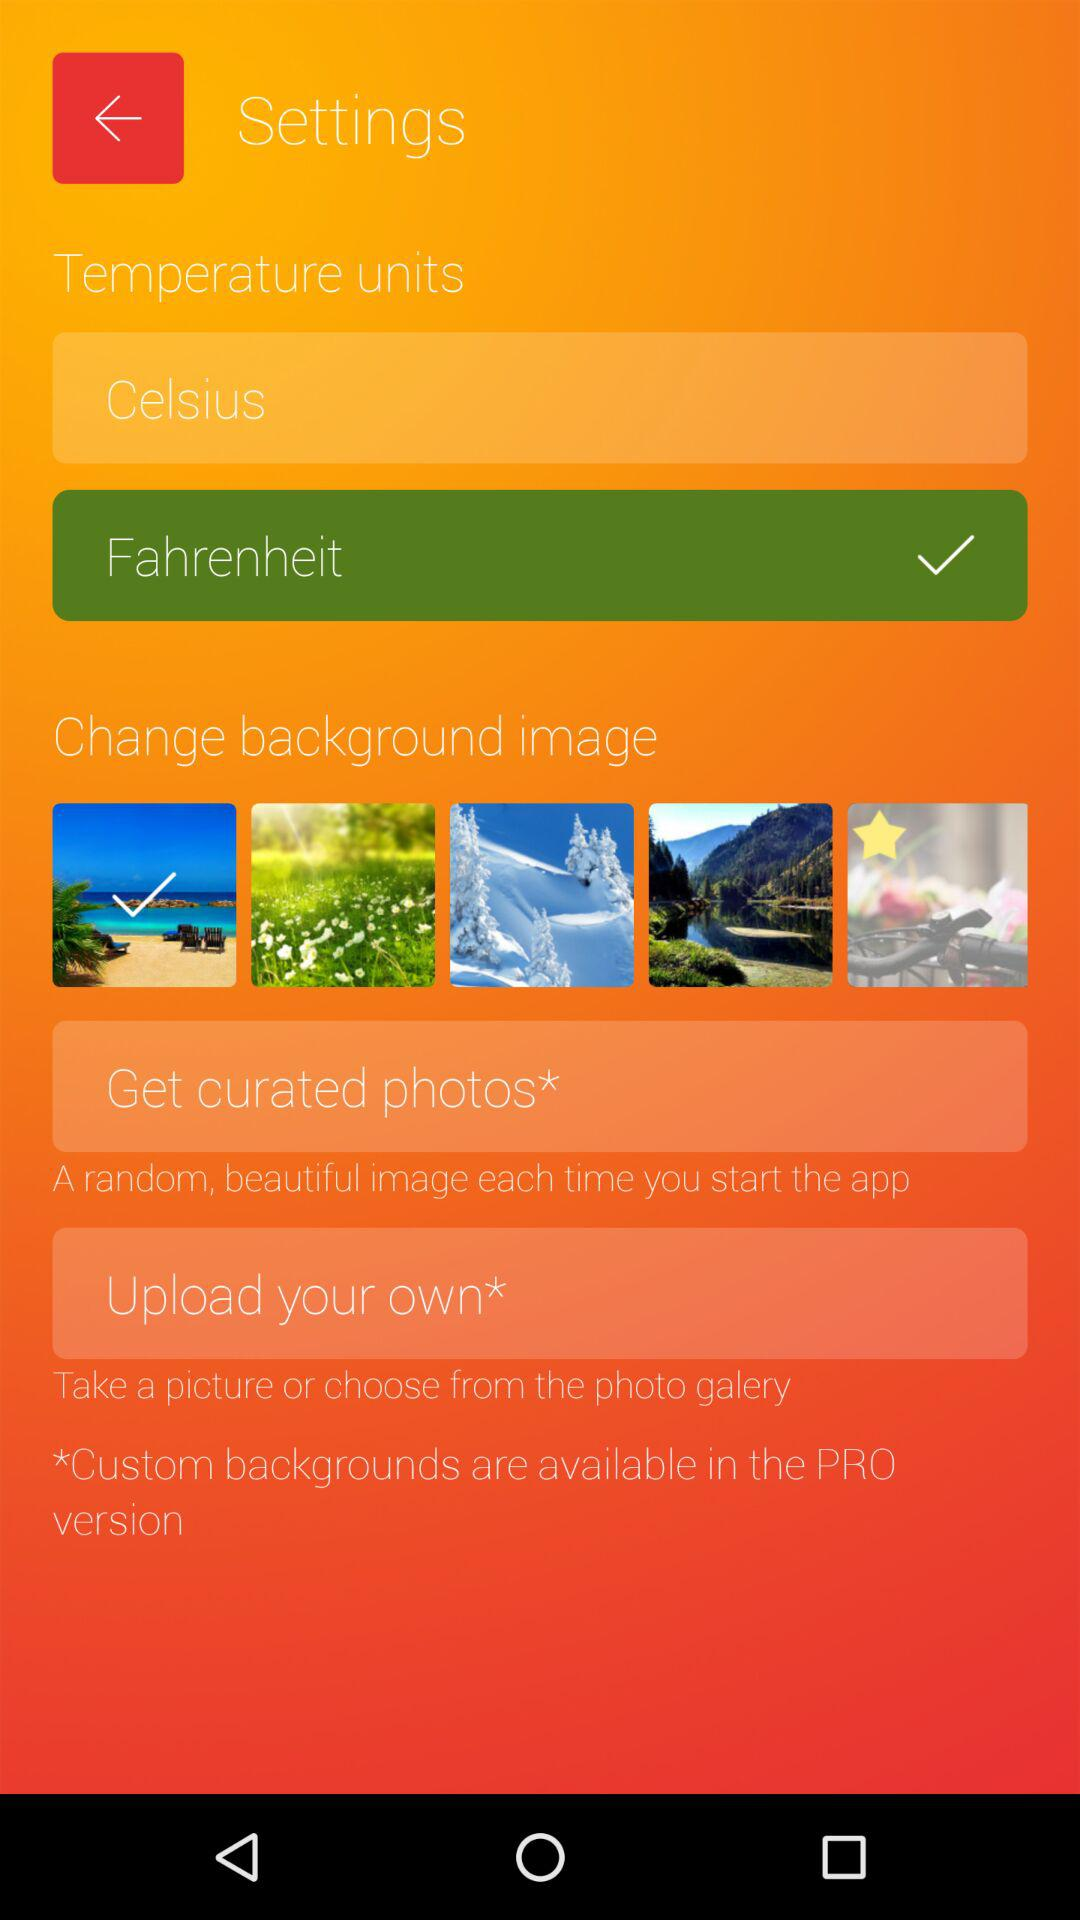What is the selected option? The selected option is "Fahrenheit". 